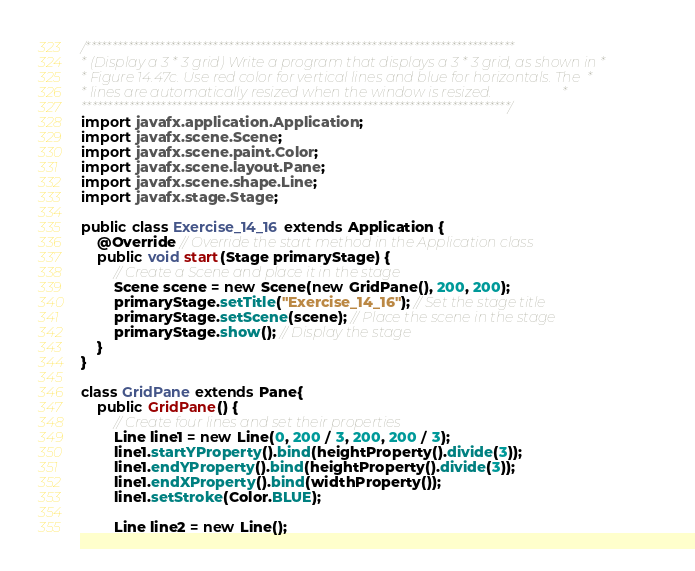<code> <loc_0><loc_0><loc_500><loc_500><_Java_>/*********************************************************************************
* (Display a 3 * 3 grid) Write a program that displays a 3 * 3 grid, as shown in *
* Figure 14.47c. Use red color for vertical lines and blue for horizontals. The  *
* lines are automatically resized when the window is resized.                    *
*********************************************************************************/
import javafx.application.Application;
import javafx.scene.Scene;
import javafx.scene.paint.Color;
import javafx.scene.layout.Pane;
import javafx.scene.shape.Line;
import javafx.stage.Stage;

public class Exercise_14_16 extends Application {
	@Override // Override the start method in the Application class
	public void start(Stage primaryStage) {
		// Create a Scene and place it in the stage
		Scene scene = new Scene(new GridPane(), 200, 200);
		primaryStage.setTitle("Exercise_14_16"); // Set the stage title
		primaryStage.setScene(scene); // Place the scene in the stage
		primaryStage.show(); // Display the stage
	}
}

class GridPane extends Pane{
	public GridPane() {
		// Create four lines and set their properties
		Line line1 = new Line(0, 200 / 3, 200, 200 / 3);
		line1.startYProperty().bind(heightProperty().divide(3));
		line1.endYProperty().bind(heightProperty().divide(3));
		line1.endXProperty().bind(widthProperty());
		line1.setStroke(Color.BLUE);

		Line line2 = new Line();</code> 